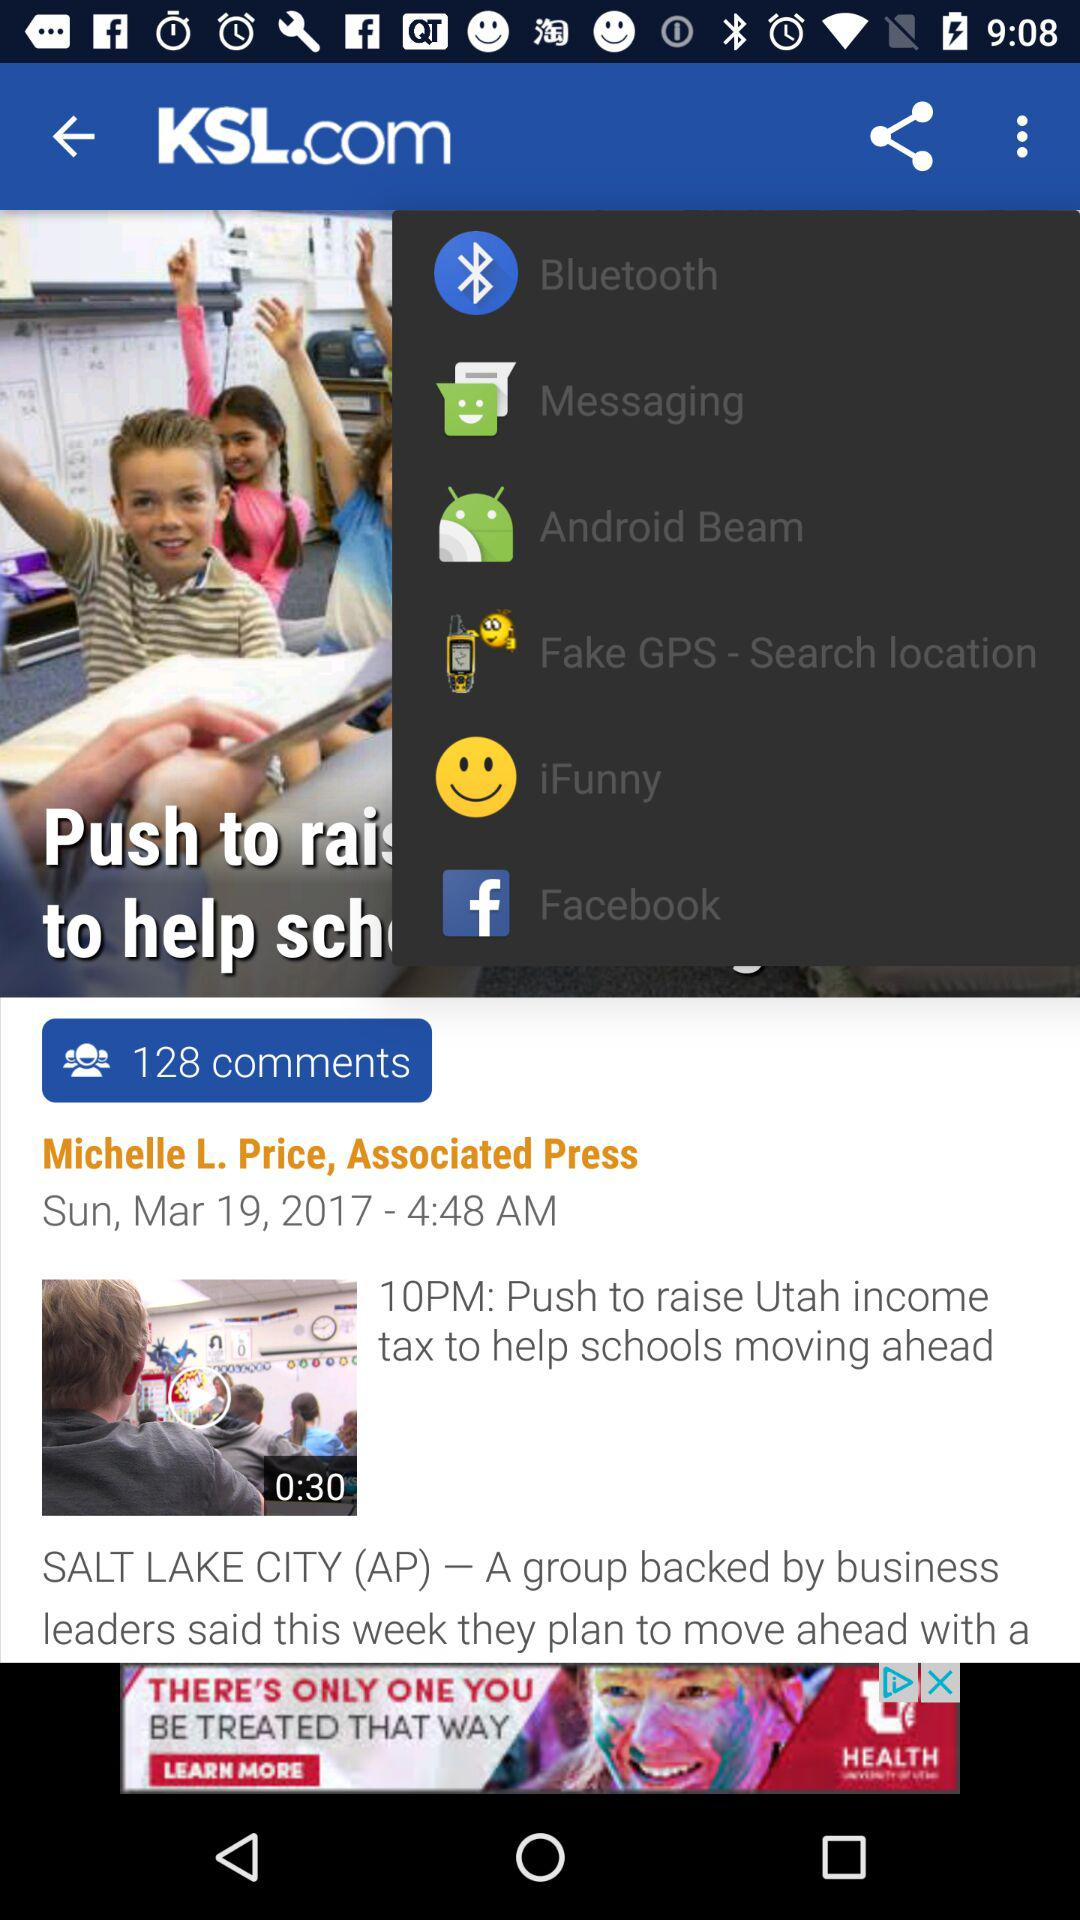What are the sharing options? The sharing options are "Bluetooth", "Messaging", "Android Beam", "Fake GPS-Search location", "iFunny", and "Facebook". 